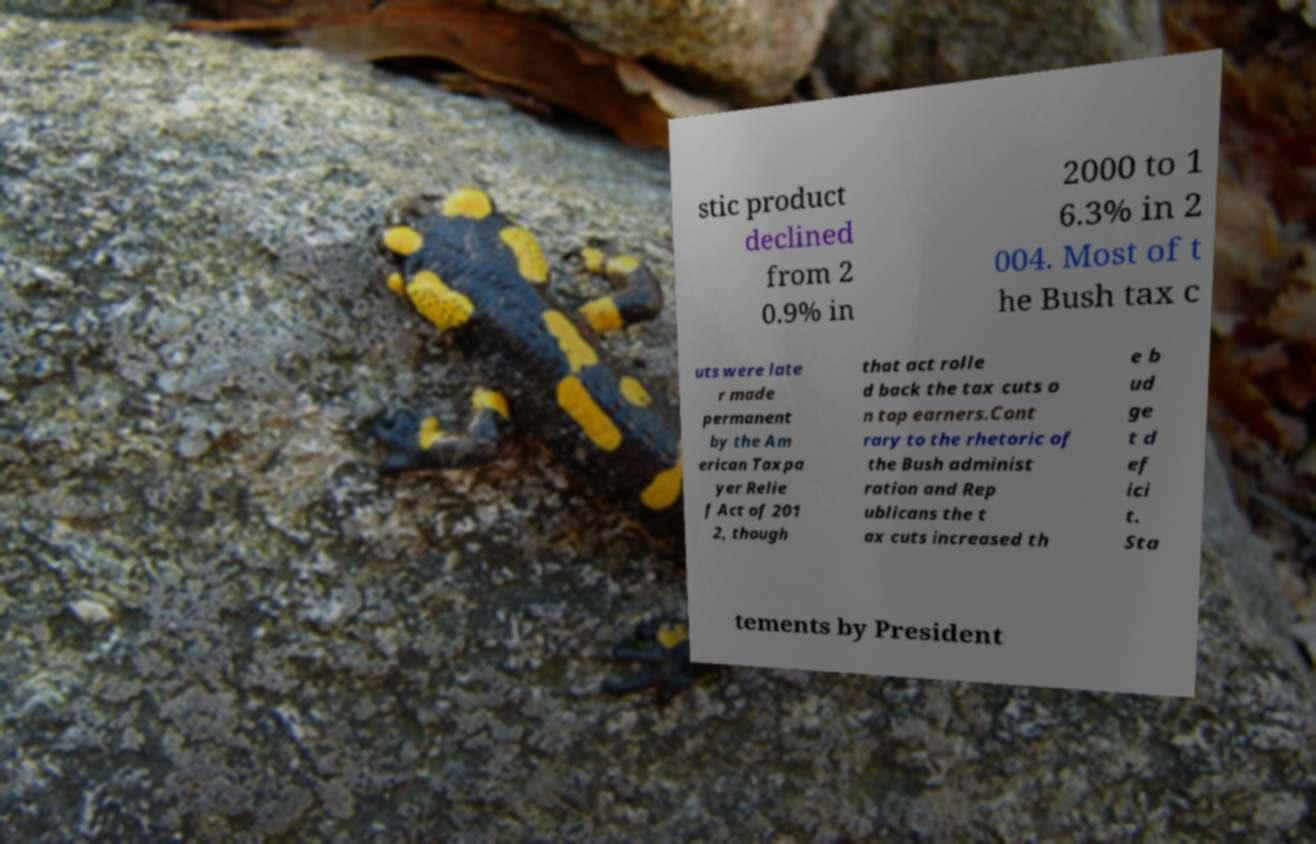Could you assist in decoding the text presented in this image and type it out clearly? stic product declined from 2 0.9% in 2000 to 1 6.3% in 2 004. Most of t he Bush tax c uts were late r made permanent by the Am erican Taxpa yer Relie f Act of 201 2, though that act rolle d back the tax cuts o n top earners.Cont rary to the rhetoric of the Bush administ ration and Rep ublicans the t ax cuts increased th e b ud ge t d ef ici t. Sta tements by President 